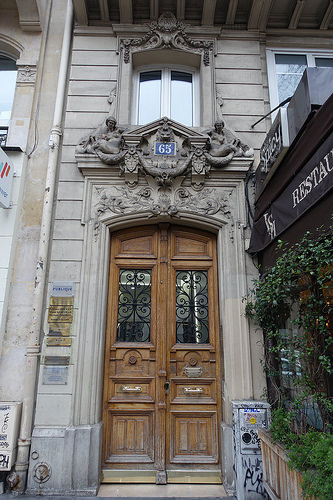<image>
Can you confirm if the door is to the left of the sign? Yes. From this viewpoint, the door is positioned to the left side relative to the sign. 